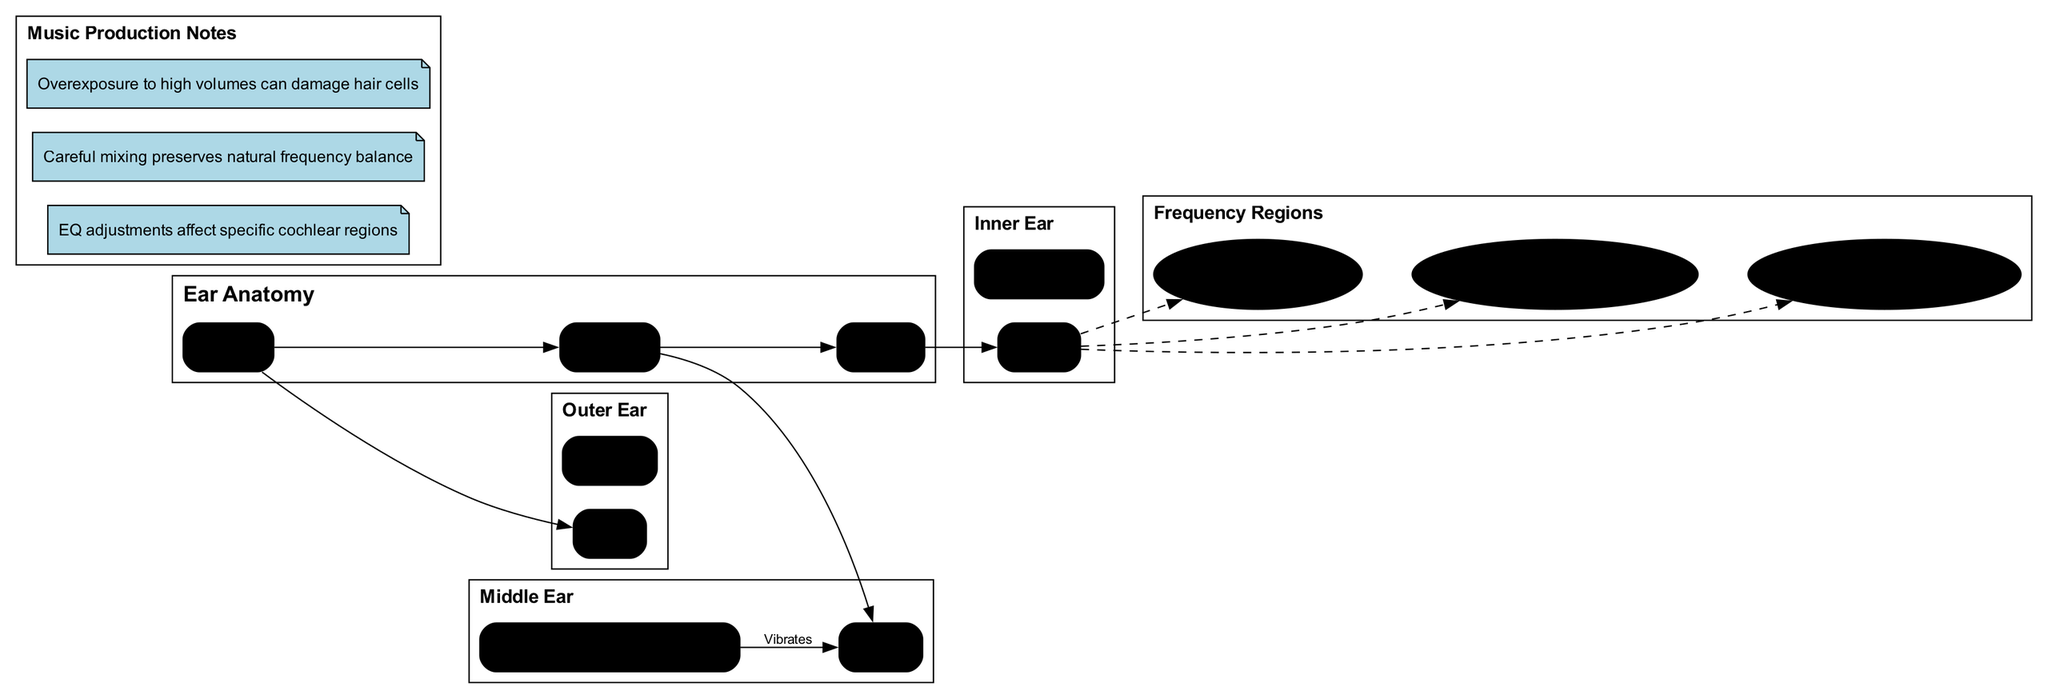What are the main components of the ear? The diagram lists three main components of the ear: Outer Ear, Middle Ear, and Inner Ear. Each component is explicitly noted, providing a clear answer.
Answer: Outer Ear, Middle Ear, Inner Ear What is located at the apex of the cochlea? According to the frequency regions section, "Bass (20-250 Hz)" is specified to be located at the Apex of Cochlea. This location is directly indicated in the diagram.
Answer: Apex of Cochlea Which part of the ear vibrates in the middle ear? The diagram indicates that the Eardrum vibrates and this action is connected in the relationship between the components listed under Middle Ear.
Answer: Eardrum How many frequency regions are shown in the diagram? The diagram lists three distinct frequency regions (Bass, Mid-range, Treble). By counting the items in the frequency regions section, the number is determined.
Answer: 3 What do EQ adjustments affect in music production? The music production notes clarify that "EQ adjustments affect specific cochlear regions", directly linking EQ adjustments to the functioning of the cochlea.
Answer: Specific cochlear regions Where do high frequencies (2000-20000 Hz) get perceived? The frequency regions section states that high frequencies are perceived at the "Base of Cochlea", indicating the specific location for treble frequencies.
Answer: Base of Cochlea What is the relationship between the ossicles and the eardrum? The diagram shows an edge labeled 'Vibrates' connecting Eardrum to Ossicles, indicating that the Eardrum vibrates which affects the Ossicles. This relationship indicates a sequential activity in sound transmission.
Answer: Vibrates What happens when there's overexposure to high volumes? There is a specific note in the music production notes that indicates "overexposure to high volumes can damage hair cells." This clarifies the impact of high volumes on ear health.
Answer: Damage hair cells In what part of the cochlea are mid-range frequencies perceived? The frequency regions specify that mid-range frequencies (250-2000 Hz) are perceived in the "Middle of Cochlea". This straightforwardly gives the answer based on the diagram's labeling.
Answer: Middle of Cochlea 